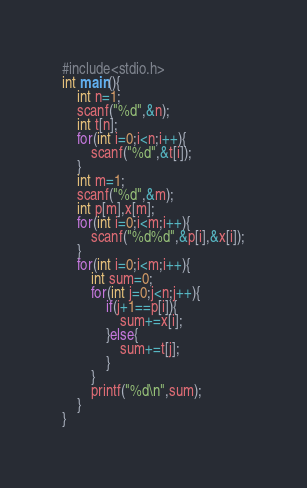Convert code to text. <code><loc_0><loc_0><loc_500><loc_500><_C_>#include<stdio.h>
int main(){
    int n=1;
    scanf("%d",&n);
    int t[n];
    for(int i=0;i<n;i++){
        scanf("%d",&t[i]);
    }
    int m=1;
    scanf("%d",&m);
    int p[m],x[m];
    for(int i=0;i<m;i++){
        scanf("%d%d",&p[i],&x[i]);
    }
    for(int i=0;i<m;i++){
        int sum=0;
        for(int j=0;j<n;j++){
            if(j+1==p[i]){
                sum+=x[i];
            }else{
                sum+=t[j];
            }
        }
        printf("%d\n",sum);
    }
}</code> 